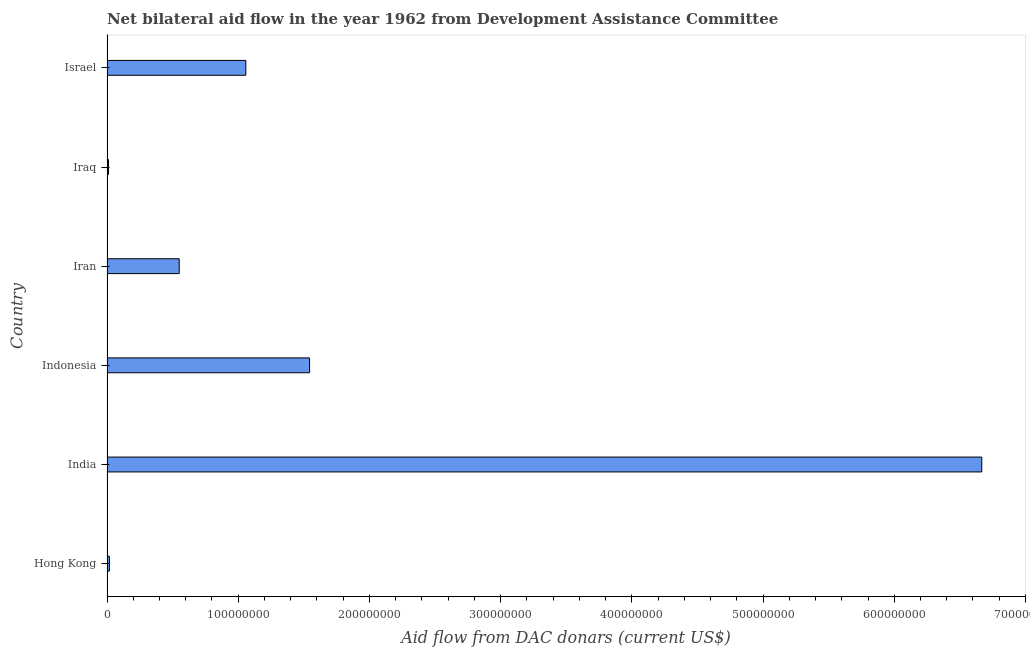What is the title of the graph?
Provide a short and direct response. Net bilateral aid flow in the year 1962 from Development Assistance Committee. What is the label or title of the X-axis?
Offer a very short reply. Aid flow from DAC donars (current US$). What is the label or title of the Y-axis?
Provide a succinct answer. Country. What is the net bilateral aid flows from dac donors in Iraq?
Provide a short and direct response. 1.15e+06. Across all countries, what is the maximum net bilateral aid flows from dac donors?
Keep it short and to the point. 6.67e+08. Across all countries, what is the minimum net bilateral aid flows from dac donors?
Give a very brief answer. 1.15e+06. In which country was the net bilateral aid flows from dac donors minimum?
Your response must be concise. Iraq. What is the sum of the net bilateral aid flows from dac donors?
Offer a terse response. 9.85e+08. What is the difference between the net bilateral aid flows from dac donors in Indonesia and Iraq?
Offer a terse response. 1.53e+08. What is the average net bilateral aid flows from dac donors per country?
Give a very brief answer. 1.64e+08. What is the median net bilateral aid flows from dac donors?
Your response must be concise. 8.04e+07. In how many countries, is the net bilateral aid flows from dac donors greater than 580000000 US$?
Offer a very short reply. 1. What is the ratio of the net bilateral aid flows from dac donors in Hong Kong to that in Indonesia?
Provide a short and direct response. 0.01. What is the difference between the highest and the second highest net bilateral aid flows from dac donors?
Offer a very short reply. 5.12e+08. What is the difference between the highest and the lowest net bilateral aid flows from dac donors?
Ensure brevity in your answer.  6.66e+08. In how many countries, is the net bilateral aid flows from dac donors greater than the average net bilateral aid flows from dac donors taken over all countries?
Ensure brevity in your answer.  1. How many bars are there?
Your answer should be compact. 6. Are all the bars in the graph horizontal?
Offer a terse response. Yes. What is the difference between two consecutive major ticks on the X-axis?
Your response must be concise. 1.00e+08. Are the values on the major ticks of X-axis written in scientific E-notation?
Your response must be concise. No. What is the Aid flow from DAC donars (current US$) of Hong Kong?
Keep it short and to the point. 1.82e+06. What is the Aid flow from DAC donars (current US$) of India?
Offer a terse response. 6.67e+08. What is the Aid flow from DAC donars (current US$) of Indonesia?
Offer a very short reply. 1.54e+08. What is the Aid flow from DAC donars (current US$) in Iran?
Provide a short and direct response. 5.50e+07. What is the Aid flow from DAC donars (current US$) of Iraq?
Your answer should be compact. 1.15e+06. What is the Aid flow from DAC donars (current US$) in Israel?
Offer a very short reply. 1.06e+08. What is the difference between the Aid flow from DAC donars (current US$) in Hong Kong and India?
Keep it short and to the point. -6.65e+08. What is the difference between the Aid flow from DAC donars (current US$) in Hong Kong and Indonesia?
Your answer should be very brief. -1.53e+08. What is the difference between the Aid flow from DAC donars (current US$) in Hong Kong and Iran?
Ensure brevity in your answer.  -5.32e+07. What is the difference between the Aid flow from DAC donars (current US$) in Hong Kong and Iraq?
Keep it short and to the point. 6.70e+05. What is the difference between the Aid flow from DAC donars (current US$) in Hong Kong and Israel?
Provide a succinct answer. -1.04e+08. What is the difference between the Aid flow from DAC donars (current US$) in India and Indonesia?
Keep it short and to the point. 5.12e+08. What is the difference between the Aid flow from DAC donars (current US$) in India and Iran?
Keep it short and to the point. 6.12e+08. What is the difference between the Aid flow from DAC donars (current US$) in India and Iraq?
Offer a very short reply. 6.66e+08. What is the difference between the Aid flow from DAC donars (current US$) in India and Israel?
Make the answer very short. 5.61e+08. What is the difference between the Aid flow from DAC donars (current US$) in Indonesia and Iran?
Your response must be concise. 9.94e+07. What is the difference between the Aid flow from DAC donars (current US$) in Indonesia and Iraq?
Give a very brief answer. 1.53e+08. What is the difference between the Aid flow from DAC donars (current US$) in Indonesia and Israel?
Offer a terse response. 4.86e+07. What is the difference between the Aid flow from DAC donars (current US$) in Iran and Iraq?
Provide a short and direct response. 5.39e+07. What is the difference between the Aid flow from DAC donars (current US$) in Iran and Israel?
Ensure brevity in your answer.  -5.08e+07. What is the difference between the Aid flow from DAC donars (current US$) in Iraq and Israel?
Your answer should be compact. -1.05e+08. What is the ratio of the Aid flow from DAC donars (current US$) in Hong Kong to that in India?
Your response must be concise. 0. What is the ratio of the Aid flow from DAC donars (current US$) in Hong Kong to that in Indonesia?
Your response must be concise. 0.01. What is the ratio of the Aid flow from DAC donars (current US$) in Hong Kong to that in Iran?
Your answer should be compact. 0.03. What is the ratio of the Aid flow from DAC donars (current US$) in Hong Kong to that in Iraq?
Offer a very short reply. 1.58. What is the ratio of the Aid flow from DAC donars (current US$) in Hong Kong to that in Israel?
Provide a short and direct response. 0.02. What is the ratio of the Aid flow from DAC donars (current US$) in India to that in Indonesia?
Give a very brief answer. 4.32. What is the ratio of the Aid flow from DAC donars (current US$) in India to that in Iran?
Your answer should be compact. 12.11. What is the ratio of the Aid flow from DAC donars (current US$) in India to that in Iraq?
Offer a very short reply. 579.74. What is the ratio of the Aid flow from DAC donars (current US$) in Indonesia to that in Iran?
Offer a very short reply. 2.81. What is the ratio of the Aid flow from DAC donars (current US$) in Indonesia to that in Iraq?
Your response must be concise. 134.25. What is the ratio of the Aid flow from DAC donars (current US$) in Indonesia to that in Israel?
Ensure brevity in your answer.  1.46. What is the ratio of the Aid flow from DAC donars (current US$) in Iran to that in Iraq?
Keep it short and to the point. 47.86. What is the ratio of the Aid flow from DAC donars (current US$) in Iran to that in Israel?
Give a very brief answer. 0.52. What is the ratio of the Aid flow from DAC donars (current US$) in Iraq to that in Israel?
Offer a very short reply. 0.01. 